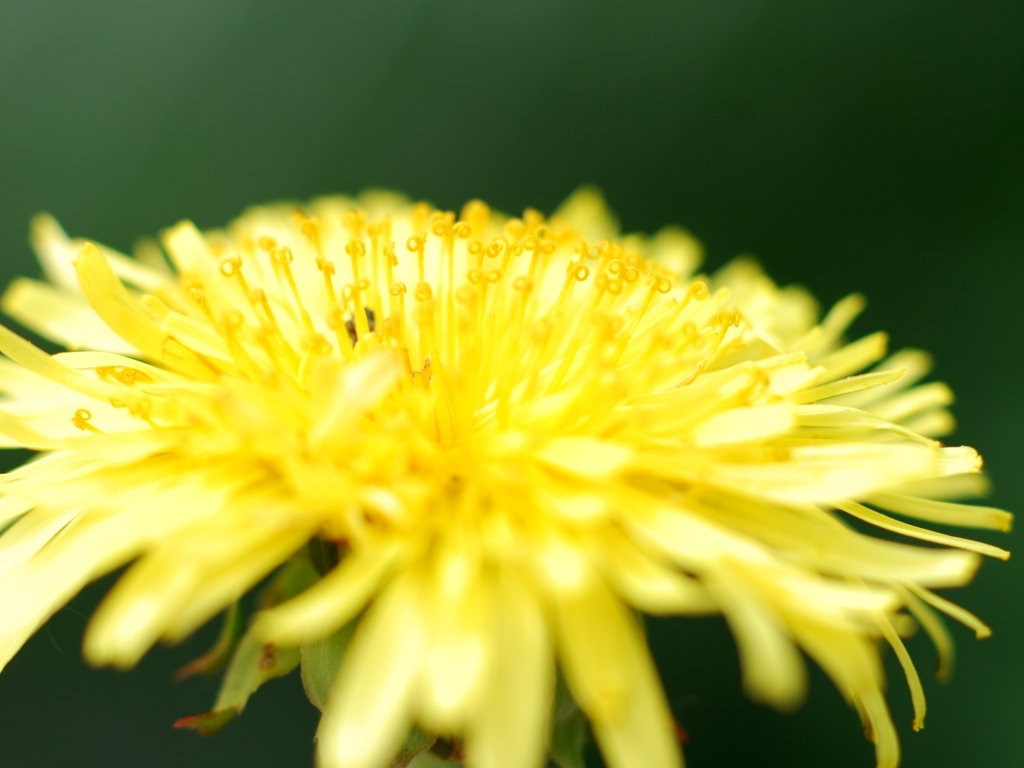Are there any interesting scientific facts about the structure of this flower? Indeed. The dandelion is an excellent example of a 'composite' flower, meaning that what appears to be one flower is actually a cluster of smaller florets. Each yellow strand is an individual floret responsible for reproduction, containing its own set of reproductive organs. This efficient structure allows dandelions to be highly resilient and successful as a species. 